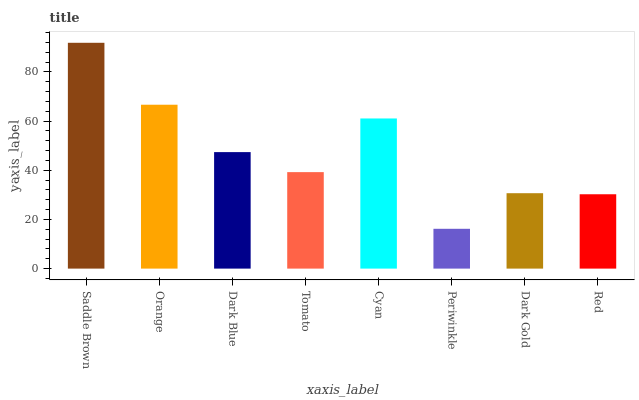Is Orange the minimum?
Answer yes or no. No. Is Orange the maximum?
Answer yes or no. No. Is Saddle Brown greater than Orange?
Answer yes or no. Yes. Is Orange less than Saddle Brown?
Answer yes or no. Yes. Is Orange greater than Saddle Brown?
Answer yes or no. No. Is Saddle Brown less than Orange?
Answer yes or no. No. Is Dark Blue the high median?
Answer yes or no. Yes. Is Tomato the low median?
Answer yes or no. Yes. Is Cyan the high median?
Answer yes or no. No. Is Saddle Brown the low median?
Answer yes or no. No. 